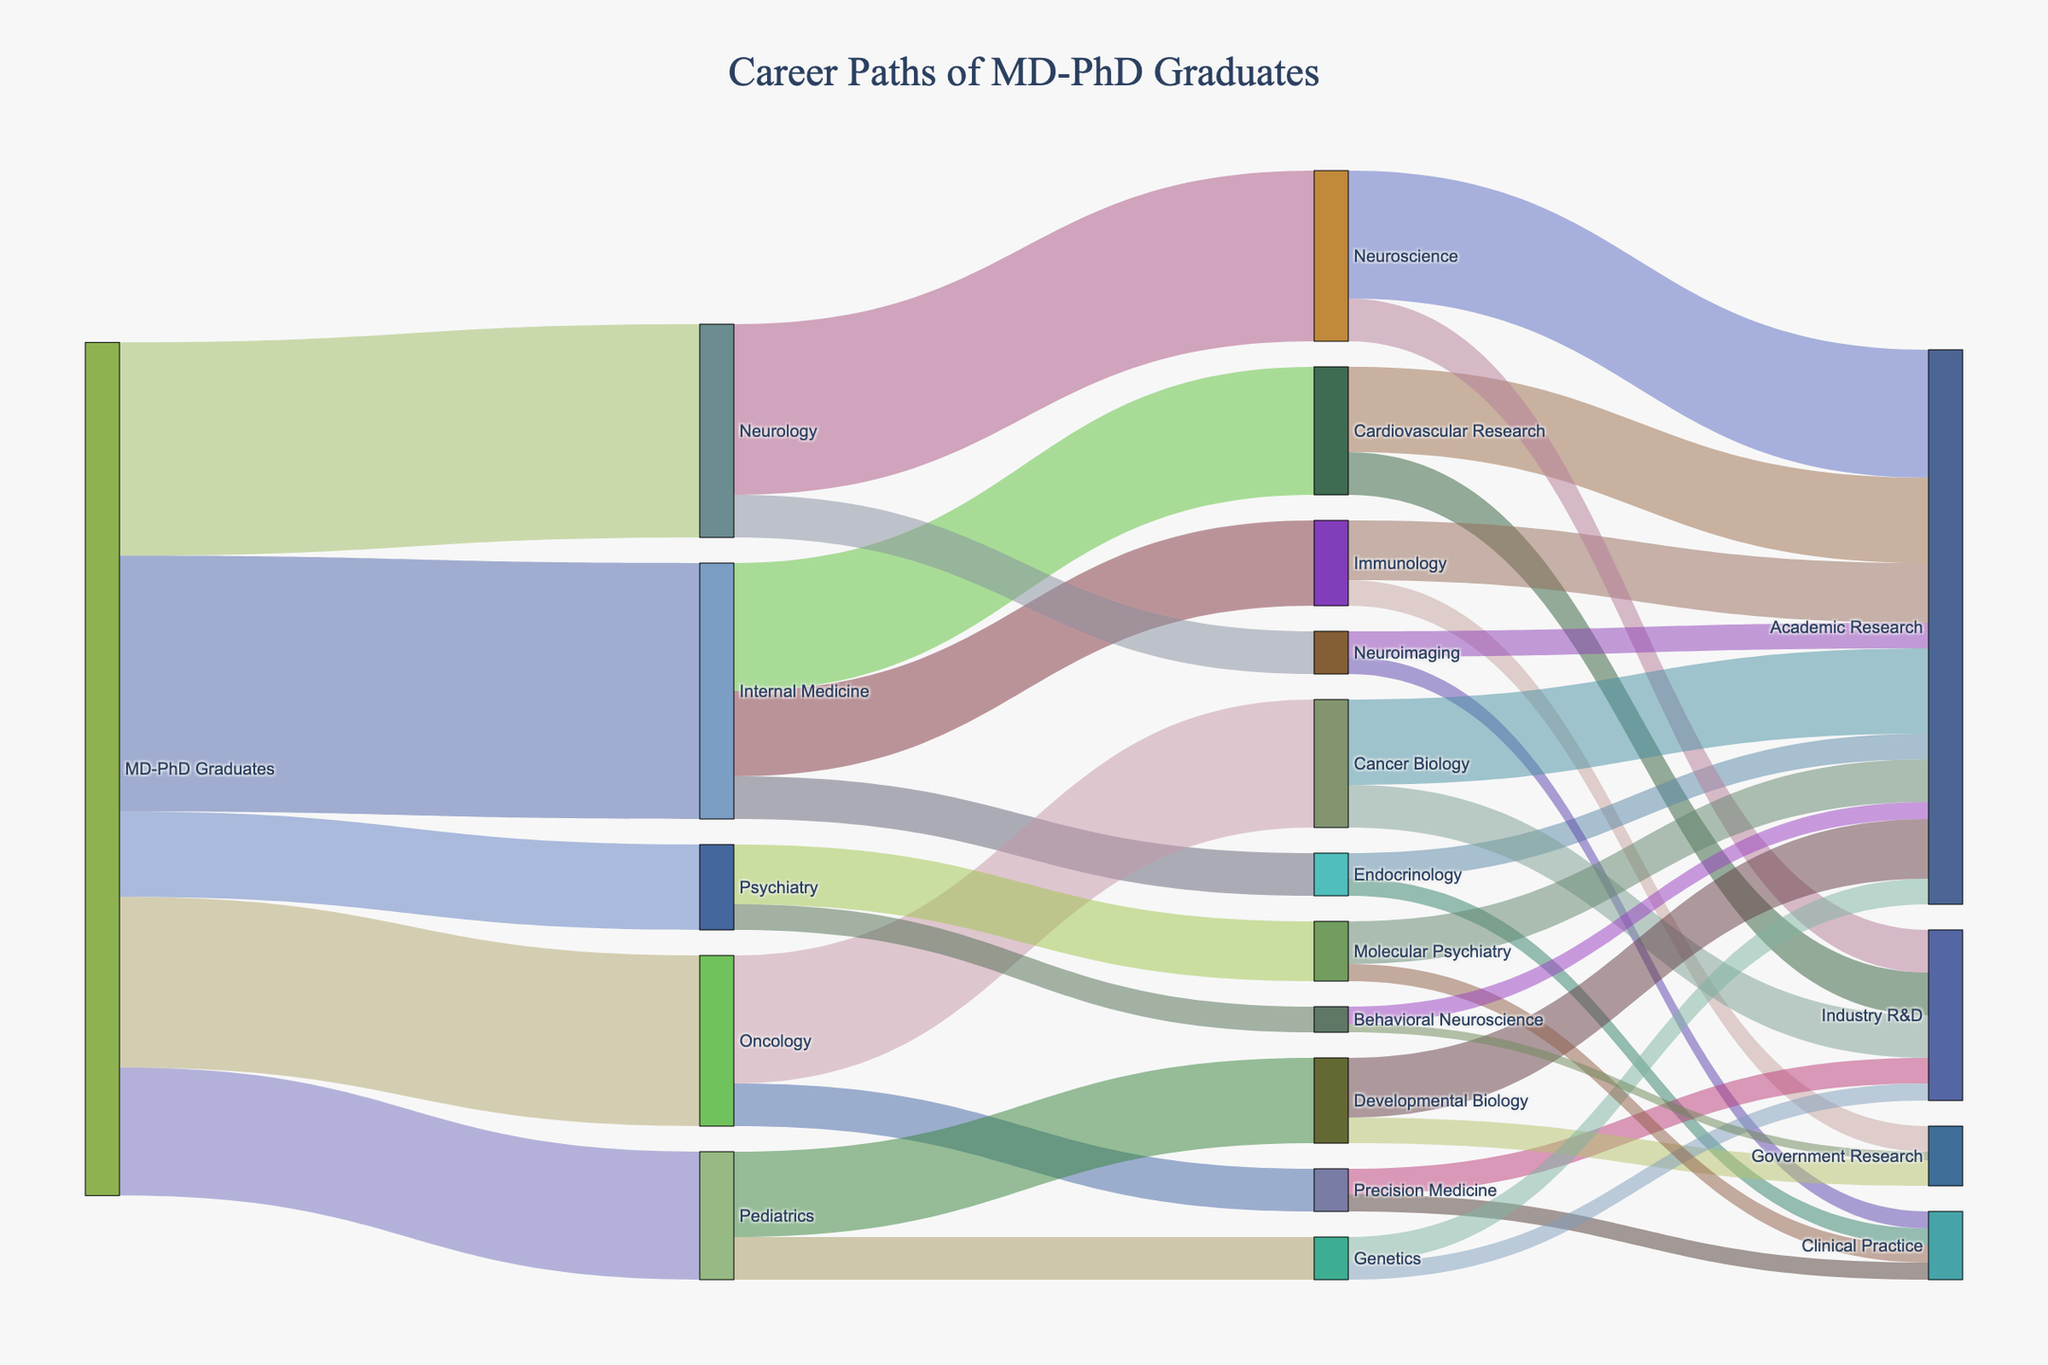What is the title of the figure? The title of the plot is typically displayed at the top of the figure. In this case, the project involves MD-PhD graduates, so the title should relate to their career paths.
Answer: Career Paths of MD-PhD Graduates Which specialty has the highest number of MD-PhD graduates? By looking at the width of the links and the associated numbers coming directly from "MD-PhD Graduates" to various specialties, identify the specialty with the largest value.
Answer: Internal Medicine How many MD-PhD graduates went into Psychiatry? Find the link from "MD-PhD Graduates" leading to "Psychiatry" and read the associated number.
Answer: 10 What is the total number of MD-PhD graduates who pursued a career in research fields related to Internal Medicine? Sum the values from "Internal Medicine" to its research fields: Cardiovascular Research (15), Immunology (10), and Endocrinology (5).
Answer: 30 Which specialty leads to the highest variety of research fields? Count the number of different research fields each specialty connects to. Internal Medicine has 3, Neurology has 2, Oncology has 2, Pediatrics has 2, and Psychiatry has 2.
Answer: Internal Medicine Which research field under Pediatrics has the most MD-PhD graduates? Compare the values of the links from "Pediatrics" to "Developmental Biology" and "Genetics".
Answer: Developmental Biology Which research field has the most MD-PhD graduates overall? Identify the research field with the largest cumulative number of graduates coming from different specialties.
Answer: Neuroscience How many MD-PhD graduates pursued careers in Government Research? Sum the values of the links pointing to "Government Research": Immunology (3), Developmental Biology (3), and Behavioral Neuroscience (1).
Answer: 7 Which specialty has the highest number of MD-PhD graduates working in Clinical Practice? Examine the links from each specialty to "Clinical Practice" and compare the values: Endocrinology (2), Neuroimaging (2), Precision Medicine (2), Molecular Psychiatry (2).
Answer: Endocrinology, Neuroimaging, Precision Medicine, Molecular Psychiatry How does the number of MD-PhD graduates in Academic Research differ between Cancer Biology and Cardiovascular Research? Subtract the value of MD-PhD graduates in Academic Research from "Cardiovascular Research" (10) and "Cancer Biology" (10).
Answer: 0 